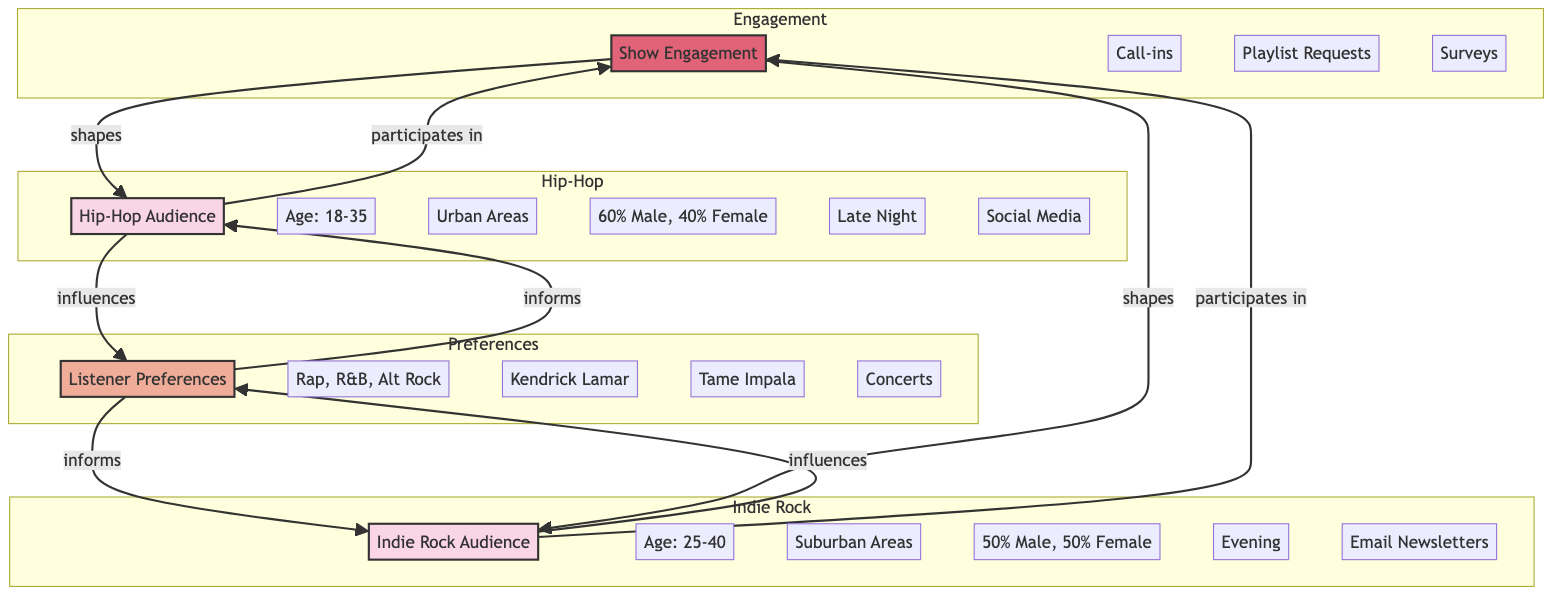What is the age range of the Hip-Hop Audience? The diagram specifically identifies the age range of the Hip-Hop Audience as "18-35".
Answer: 18-35 What percentage of the Indie Rock Audience is female? The diagram shows that the gender breakdown for the Indie Rock Audience is 50% Male and 50% Female, so the percentage of females is 50%.
Answer: 50% How many key locations are identified for the Hip-Hop Audience? According to the diagram, the Hip-Hop Audience has two key locations listed: "Urban Areas" and "College Towns". Therefore, the total number of key locations is 2.
Answer: 2 What types of interactions are categorized under Show Engagement? The diagram lists two interaction types for Show Engagement: "Call-ins" and "Playlist Requests", therefore, the types of interactions are two.
Answer: Call-ins, Playlist Requests Which demographics influence listener preferences? The diagram indicates that both the Hip-Hop and Indie Rock Audiences influence listener preferences. Since they are the only audiences mentioned in the context of the node "Listener Preferences," they both contribute to it.
Answer: Hip-Hop Audience, Indie Rock Audience What are the common genres listed under Listener Preferences? The diagram specifies that the common genres under Listener Preferences include "Rap", "R&B", and "Alternative Rock".
Answer: Rap, R&B, Alternative Rock Which audience has a higher percentage of males? Upon examining the gender breakdowns, the Hip-Hop Audience consists of 60% males while the Indie Rock Audience consists of 50% males. Thus, the Hip-Hop Audience has a higher percentage of males.
Answer: Hip-Hop Audience What shape is the relationship between the Hip-Hop Audience and Show Engagement? The diagram indicates that the Hip-Hop Audience participates in Show Engagement. This participation can be visually interpreted as a directed arrow leading from the Hip-Hop Audience to Show Engagement, establishing a clear influence relationship.
Answer: Influences How do preferences inform the audiences according to the diagram? The diagram shows an arrow that represents the influence of Listener Preferences back to both the Hip-Hop Audience and Indie Rock Audience, indicating that listener preferences inform both audiences about their content and engagement strategies.
Answer: Influences 